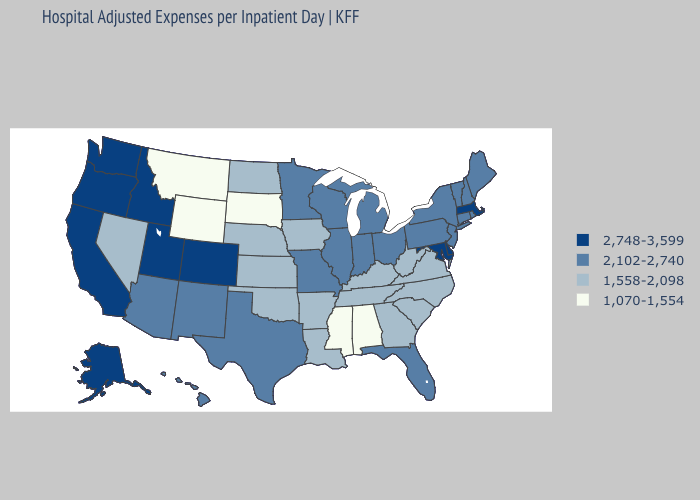Does Idaho have the lowest value in the West?
Keep it brief. No. Among the states that border Montana , does Wyoming have the lowest value?
Keep it brief. Yes. Name the states that have a value in the range 2,748-3,599?
Quick response, please. Alaska, California, Colorado, Delaware, Idaho, Maryland, Massachusetts, Oregon, Utah, Washington. Does Montana have the lowest value in the USA?
Write a very short answer. Yes. What is the value of Nevada?
Answer briefly. 1,558-2,098. Among the states that border Indiana , does Michigan have the lowest value?
Be succinct. No. What is the value of Minnesota?
Keep it brief. 2,102-2,740. Does New Hampshire have a lower value than Maine?
Give a very brief answer. No. What is the highest value in states that border Nevada?
Keep it brief. 2,748-3,599. What is the value of Arizona?
Write a very short answer. 2,102-2,740. Does North Carolina have a lower value than Wyoming?
Be succinct. No. Name the states that have a value in the range 2,748-3,599?
Short answer required. Alaska, California, Colorado, Delaware, Idaho, Maryland, Massachusetts, Oregon, Utah, Washington. Name the states that have a value in the range 1,558-2,098?
Keep it brief. Arkansas, Georgia, Iowa, Kansas, Kentucky, Louisiana, Nebraska, Nevada, North Carolina, North Dakota, Oklahoma, South Carolina, Tennessee, Virginia, West Virginia. 